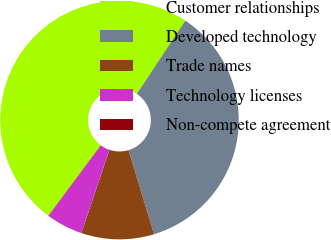Convert chart. <chart><loc_0><loc_0><loc_500><loc_500><pie_chart><fcel>Customer relationships<fcel>Developed technology<fcel>Trade names<fcel>Technology licenses<fcel>Non-compete agreement<nl><fcel>49.14%<fcel>36.03%<fcel>9.86%<fcel>4.95%<fcel>0.04%<nl></chart> 